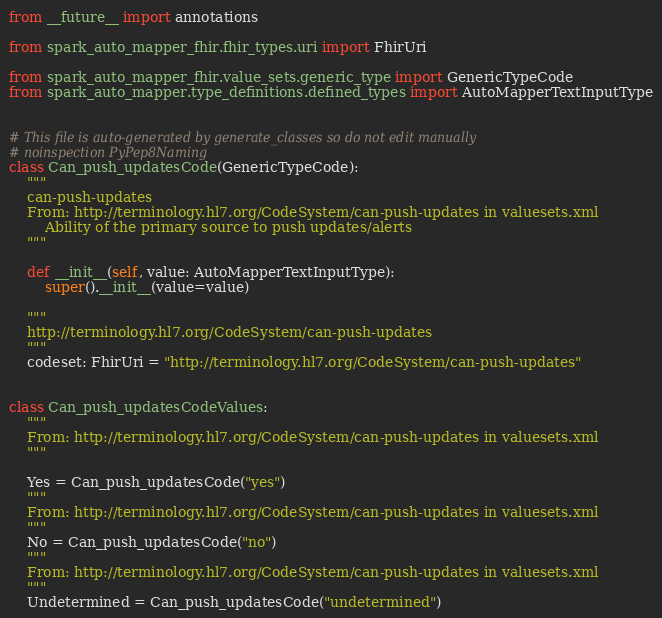<code> <loc_0><loc_0><loc_500><loc_500><_Python_>from __future__ import annotations

from spark_auto_mapper_fhir.fhir_types.uri import FhirUri

from spark_auto_mapper_fhir.value_sets.generic_type import GenericTypeCode
from spark_auto_mapper.type_definitions.defined_types import AutoMapperTextInputType


# This file is auto-generated by generate_classes so do not edit manually
# noinspection PyPep8Naming
class Can_push_updatesCode(GenericTypeCode):
    """
    can-push-updates
    From: http://terminology.hl7.org/CodeSystem/can-push-updates in valuesets.xml
        Ability of the primary source to push updates/alerts
    """

    def __init__(self, value: AutoMapperTextInputType):
        super().__init__(value=value)

    """
    http://terminology.hl7.org/CodeSystem/can-push-updates
    """
    codeset: FhirUri = "http://terminology.hl7.org/CodeSystem/can-push-updates"


class Can_push_updatesCodeValues:
    """
    From: http://terminology.hl7.org/CodeSystem/can-push-updates in valuesets.xml
    """

    Yes = Can_push_updatesCode("yes")
    """
    From: http://terminology.hl7.org/CodeSystem/can-push-updates in valuesets.xml
    """
    No = Can_push_updatesCode("no")
    """
    From: http://terminology.hl7.org/CodeSystem/can-push-updates in valuesets.xml
    """
    Undetermined = Can_push_updatesCode("undetermined")
</code> 